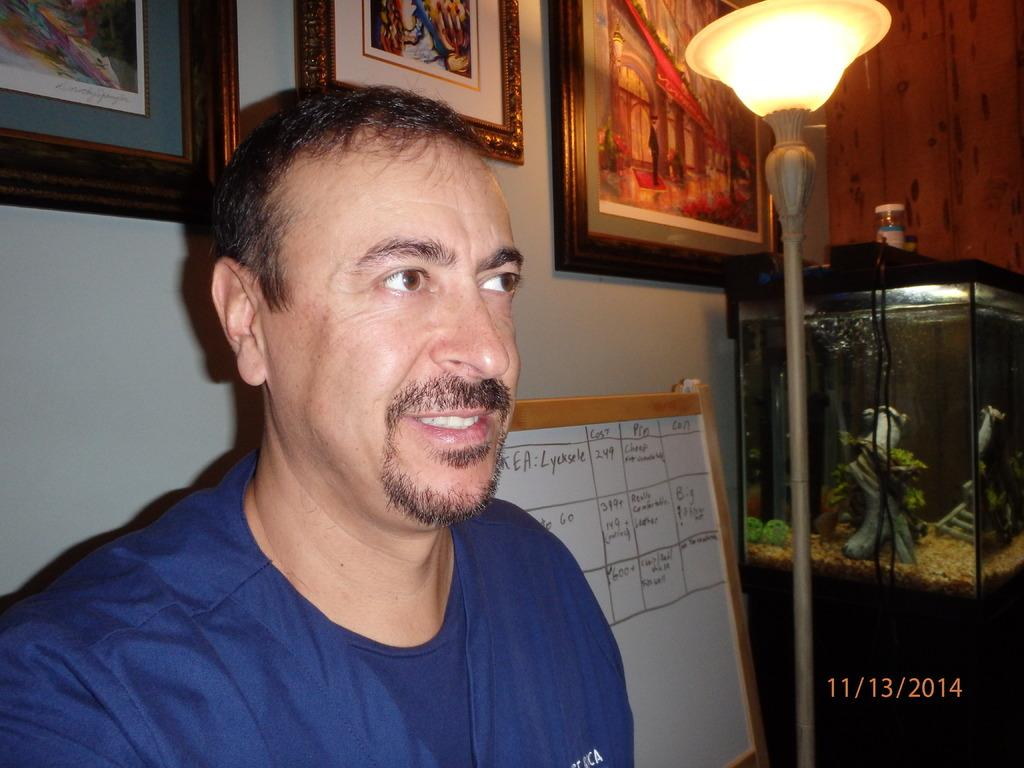Who or what is present in the image? There is a person in the image. What can be seen on the wall in the image? There are frames attached to the wall. What is written or displayed on a board in the image? There is a board with text in the image. What type of lighting is present in the image? There is a light attached to a pole in the image. What is placed on top of the aquarium in the image? There are bottles on an aquarium in the image. How many ducks are resting on the person's head in the image? There are no ducks present in the image, and therefore no ducks are resting on the person's head. 